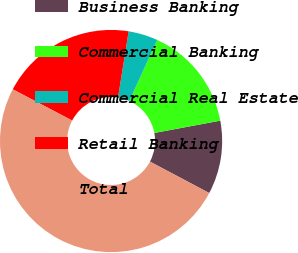Convert chart. <chart><loc_0><loc_0><loc_500><loc_500><pie_chart><fcel>Business Banking<fcel>Commercial Banking<fcel>Commercial Real Estate<fcel>Retail Banking<fcel>Total<nl><fcel>10.69%<fcel>15.25%<fcel>4.29%<fcel>19.82%<fcel>49.95%<nl></chart> 